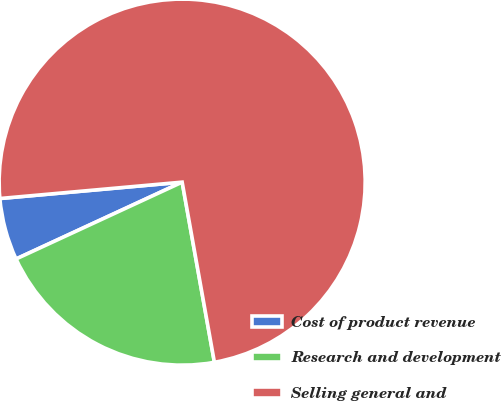Convert chart. <chart><loc_0><loc_0><loc_500><loc_500><pie_chart><fcel>Cost of product revenue<fcel>Research and development<fcel>Selling general and<nl><fcel>5.47%<fcel>20.92%<fcel>73.6%<nl></chart> 